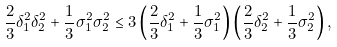Convert formula to latex. <formula><loc_0><loc_0><loc_500><loc_500>\frac { 2 } { 3 } \delta _ { 1 } ^ { 2 } \delta _ { 2 } ^ { 2 } + \frac { 1 } { 3 } \sigma _ { 1 } ^ { 2 } \sigma _ { 2 } ^ { 2 } \leq 3 \left ( \frac { 2 } { 3 } \delta _ { 1 } ^ { 2 } + \frac { 1 } { 3 } \sigma _ { 1 } ^ { 2 } \right ) \left ( \frac { 2 } { 3 } \delta _ { 2 } ^ { 2 } + \frac { 1 } { 3 } \sigma _ { 2 } ^ { 2 } \right ) ,</formula> 